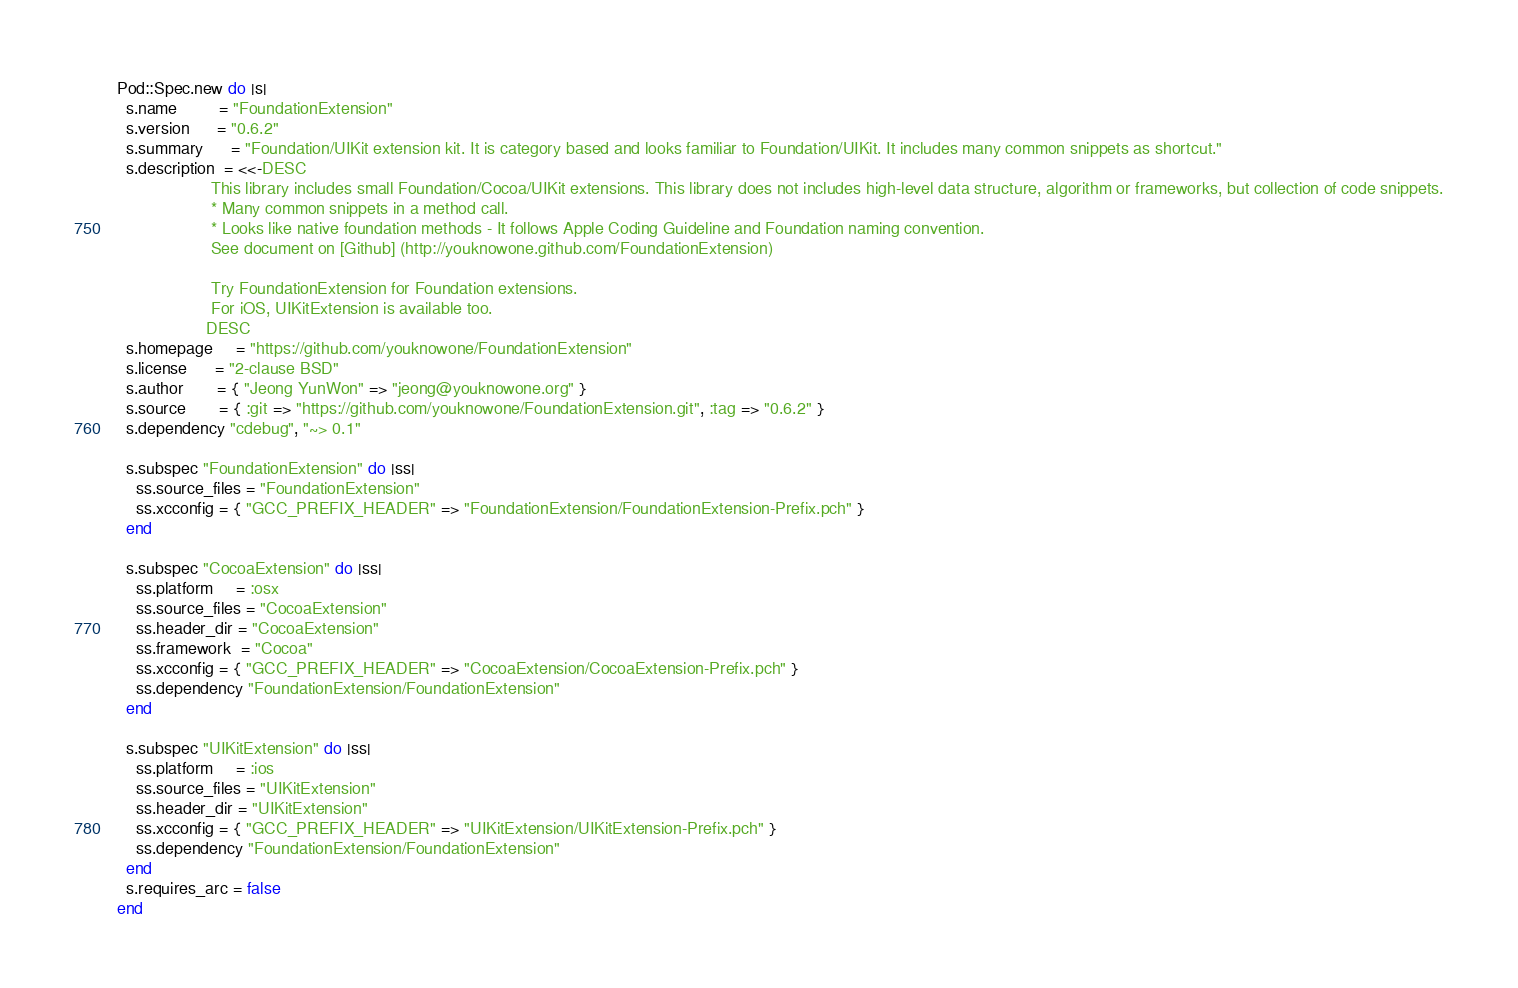Convert code to text. <code><loc_0><loc_0><loc_500><loc_500><_Ruby_>Pod::Spec.new do |s|
  s.name         = "FoundationExtension"
  s.version      = "0.6.2"
  s.summary      = "Foundation/UIKit extension kit. It is category based and looks familiar to Foundation/UIKit. It includes many common snippets as shortcut."
  s.description  = <<-DESC
                    This library includes small Foundation/Cocoa/UIKit extensions. This library does not includes high-level data structure, algorithm or frameworks, but collection of code snippets.
                    * Many common snippets in a method call.
                    * Looks like native foundation methods - It follows Apple Coding Guideline and Foundation naming convention.
                    See document on [Github] (http://youknowone.github.com/FoundationExtension)

                    Try FoundationExtension for Foundation extensions.
                    For iOS, UIKitExtension is available too.
                   DESC
  s.homepage     = "https://github.com/youknowone/FoundationExtension"
  s.license      = "2-clause BSD"
  s.author       = { "Jeong YunWon" => "jeong@youknowone.org" }
  s.source       = { :git => "https://github.com/youknowone/FoundationExtension.git", :tag => "0.6.2" }
  s.dependency "cdebug", "~> 0.1"

  s.subspec "FoundationExtension" do |ss|
    ss.source_files = "FoundationExtension"
    ss.xcconfig = { "GCC_PREFIX_HEADER" => "FoundationExtension/FoundationExtension-Prefix.pch" }
  end

  s.subspec "CocoaExtension" do |ss|
    ss.platform     = :osx
    ss.source_files = "CocoaExtension"
    ss.header_dir = "CocoaExtension"
    ss.framework  = "Cocoa"
    ss.xcconfig = { "GCC_PREFIX_HEADER" => "CocoaExtension/CocoaExtension-Prefix.pch" }
    ss.dependency "FoundationExtension/FoundationExtension"
  end

  s.subspec "UIKitExtension" do |ss|
    ss.platform     = :ios
    ss.source_files = "UIKitExtension"
    ss.header_dir = "UIKitExtension"
    ss.xcconfig = { "GCC_PREFIX_HEADER" => "UIKitExtension/UIKitExtension-Prefix.pch" }
    ss.dependency "FoundationExtension/FoundationExtension"
  end
  s.requires_arc = false
end
</code> 